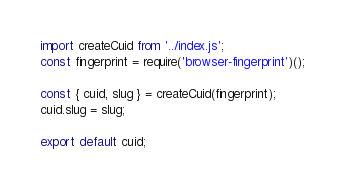Convert code to text. <code><loc_0><loc_0><loc_500><loc_500><_JavaScript_>import createCuid from '../index.js';
const fingerprint = require('browser-fingerprint')();

const { cuid, slug } = createCuid(fingerprint);
cuid.slug = slug;

export default cuid;
</code> 